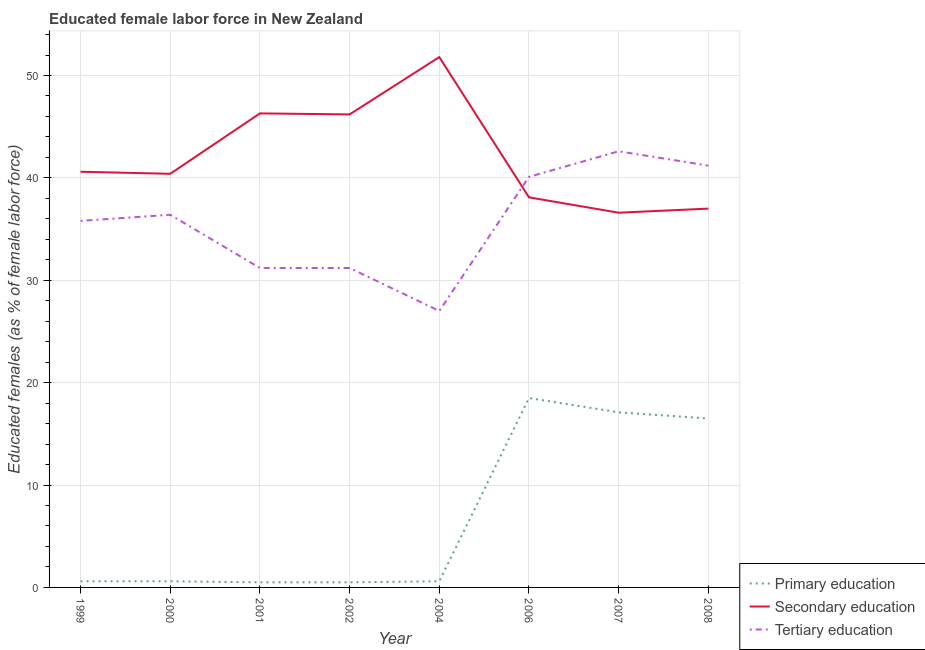How many different coloured lines are there?
Your answer should be compact. 3. What is the percentage of female labor force who received tertiary education in 1999?
Your response must be concise. 35.8. Across all years, what is the maximum percentage of female labor force who received primary education?
Your answer should be compact. 18.5. Across all years, what is the minimum percentage of female labor force who received secondary education?
Provide a succinct answer. 36.6. In which year was the percentage of female labor force who received tertiary education minimum?
Provide a succinct answer. 2004. What is the total percentage of female labor force who received tertiary education in the graph?
Give a very brief answer. 285.5. What is the difference between the percentage of female labor force who received tertiary education in 2007 and that in 2008?
Ensure brevity in your answer.  1.4. What is the difference between the percentage of female labor force who received primary education in 2006 and the percentage of female labor force who received secondary education in 2000?
Make the answer very short. -21.9. What is the average percentage of female labor force who received primary education per year?
Give a very brief answer. 6.86. In the year 2004, what is the difference between the percentage of female labor force who received secondary education and percentage of female labor force who received primary education?
Make the answer very short. 51.2. What is the ratio of the percentage of female labor force who received primary education in 1999 to that in 2006?
Your answer should be compact. 0.03. Is the percentage of female labor force who received secondary education in 2000 less than that in 2006?
Ensure brevity in your answer.  No. What is the difference between the highest and the lowest percentage of female labor force who received tertiary education?
Provide a succinct answer. 15.6. In how many years, is the percentage of female labor force who received tertiary education greater than the average percentage of female labor force who received tertiary education taken over all years?
Make the answer very short. 5. Does the percentage of female labor force who received primary education monotonically increase over the years?
Offer a terse response. No. Is the percentage of female labor force who received secondary education strictly greater than the percentage of female labor force who received primary education over the years?
Ensure brevity in your answer.  Yes. Is the percentage of female labor force who received primary education strictly less than the percentage of female labor force who received tertiary education over the years?
Keep it short and to the point. Yes. How many lines are there?
Keep it short and to the point. 3. Does the graph contain grids?
Provide a short and direct response. Yes. How are the legend labels stacked?
Your answer should be compact. Vertical. What is the title of the graph?
Provide a short and direct response. Educated female labor force in New Zealand. What is the label or title of the X-axis?
Give a very brief answer. Year. What is the label or title of the Y-axis?
Ensure brevity in your answer.  Educated females (as % of female labor force). What is the Educated females (as % of female labor force) of Primary education in 1999?
Provide a short and direct response. 0.6. What is the Educated females (as % of female labor force) of Secondary education in 1999?
Give a very brief answer. 40.6. What is the Educated females (as % of female labor force) of Tertiary education in 1999?
Offer a terse response. 35.8. What is the Educated females (as % of female labor force) in Primary education in 2000?
Keep it short and to the point. 0.6. What is the Educated females (as % of female labor force) in Secondary education in 2000?
Offer a terse response. 40.4. What is the Educated females (as % of female labor force) in Tertiary education in 2000?
Offer a terse response. 36.4. What is the Educated females (as % of female labor force) in Primary education in 2001?
Offer a terse response. 0.5. What is the Educated females (as % of female labor force) of Secondary education in 2001?
Your response must be concise. 46.3. What is the Educated females (as % of female labor force) of Tertiary education in 2001?
Ensure brevity in your answer.  31.2. What is the Educated females (as % of female labor force) of Secondary education in 2002?
Provide a short and direct response. 46.2. What is the Educated females (as % of female labor force) of Tertiary education in 2002?
Provide a succinct answer. 31.2. What is the Educated females (as % of female labor force) in Primary education in 2004?
Provide a short and direct response. 0.6. What is the Educated females (as % of female labor force) in Secondary education in 2004?
Keep it short and to the point. 51.8. What is the Educated females (as % of female labor force) of Tertiary education in 2004?
Provide a succinct answer. 27. What is the Educated females (as % of female labor force) in Secondary education in 2006?
Make the answer very short. 38.1. What is the Educated females (as % of female labor force) in Tertiary education in 2006?
Offer a very short reply. 40.1. What is the Educated females (as % of female labor force) of Primary education in 2007?
Provide a short and direct response. 17.1. What is the Educated females (as % of female labor force) of Secondary education in 2007?
Your answer should be compact. 36.6. What is the Educated females (as % of female labor force) in Tertiary education in 2007?
Keep it short and to the point. 42.6. What is the Educated females (as % of female labor force) in Secondary education in 2008?
Your answer should be compact. 37. What is the Educated females (as % of female labor force) of Tertiary education in 2008?
Offer a terse response. 41.2. Across all years, what is the maximum Educated females (as % of female labor force) of Secondary education?
Provide a succinct answer. 51.8. Across all years, what is the maximum Educated females (as % of female labor force) in Tertiary education?
Provide a succinct answer. 42.6. Across all years, what is the minimum Educated females (as % of female labor force) in Secondary education?
Make the answer very short. 36.6. Across all years, what is the minimum Educated females (as % of female labor force) of Tertiary education?
Ensure brevity in your answer.  27. What is the total Educated females (as % of female labor force) in Primary education in the graph?
Your answer should be compact. 54.9. What is the total Educated females (as % of female labor force) of Secondary education in the graph?
Make the answer very short. 337. What is the total Educated females (as % of female labor force) of Tertiary education in the graph?
Make the answer very short. 285.5. What is the difference between the Educated females (as % of female labor force) in Primary education in 1999 and that in 2000?
Give a very brief answer. 0. What is the difference between the Educated females (as % of female labor force) of Secondary education in 1999 and that in 2000?
Make the answer very short. 0.2. What is the difference between the Educated females (as % of female labor force) of Tertiary education in 1999 and that in 2000?
Offer a very short reply. -0.6. What is the difference between the Educated females (as % of female labor force) of Primary education in 1999 and that in 2001?
Offer a very short reply. 0.1. What is the difference between the Educated females (as % of female labor force) in Secondary education in 1999 and that in 2001?
Make the answer very short. -5.7. What is the difference between the Educated females (as % of female labor force) in Tertiary education in 1999 and that in 2001?
Provide a short and direct response. 4.6. What is the difference between the Educated females (as % of female labor force) in Secondary education in 1999 and that in 2004?
Your response must be concise. -11.2. What is the difference between the Educated females (as % of female labor force) of Primary education in 1999 and that in 2006?
Ensure brevity in your answer.  -17.9. What is the difference between the Educated females (as % of female labor force) of Tertiary education in 1999 and that in 2006?
Your answer should be compact. -4.3. What is the difference between the Educated females (as % of female labor force) of Primary education in 1999 and that in 2007?
Provide a succinct answer. -16.5. What is the difference between the Educated females (as % of female labor force) in Tertiary education in 1999 and that in 2007?
Provide a succinct answer. -6.8. What is the difference between the Educated females (as % of female labor force) of Primary education in 1999 and that in 2008?
Your answer should be very brief. -15.9. What is the difference between the Educated females (as % of female labor force) of Tertiary education in 1999 and that in 2008?
Offer a very short reply. -5.4. What is the difference between the Educated females (as % of female labor force) in Secondary education in 2000 and that in 2001?
Offer a terse response. -5.9. What is the difference between the Educated females (as % of female labor force) of Primary education in 2000 and that in 2002?
Offer a terse response. 0.1. What is the difference between the Educated females (as % of female labor force) in Tertiary education in 2000 and that in 2002?
Make the answer very short. 5.2. What is the difference between the Educated females (as % of female labor force) of Primary education in 2000 and that in 2004?
Your answer should be compact. 0. What is the difference between the Educated females (as % of female labor force) of Primary education in 2000 and that in 2006?
Your response must be concise. -17.9. What is the difference between the Educated females (as % of female labor force) in Secondary education in 2000 and that in 2006?
Give a very brief answer. 2.3. What is the difference between the Educated females (as % of female labor force) of Tertiary education in 2000 and that in 2006?
Keep it short and to the point. -3.7. What is the difference between the Educated females (as % of female labor force) of Primary education in 2000 and that in 2007?
Keep it short and to the point. -16.5. What is the difference between the Educated females (as % of female labor force) of Primary education in 2000 and that in 2008?
Your answer should be compact. -15.9. What is the difference between the Educated females (as % of female labor force) of Secondary education in 2000 and that in 2008?
Provide a short and direct response. 3.4. What is the difference between the Educated females (as % of female labor force) of Secondary education in 2001 and that in 2002?
Make the answer very short. 0.1. What is the difference between the Educated females (as % of female labor force) in Tertiary education in 2001 and that in 2002?
Provide a short and direct response. 0. What is the difference between the Educated females (as % of female labor force) of Secondary education in 2001 and that in 2004?
Keep it short and to the point. -5.5. What is the difference between the Educated females (as % of female labor force) in Primary education in 2001 and that in 2006?
Keep it short and to the point. -18. What is the difference between the Educated females (as % of female labor force) of Primary education in 2001 and that in 2007?
Provide a succinct answer. -16.6. What is the difference between the Educated females (as % of female labor force) in Tertiary education in 2001 and that in 2007?
Your answer should be very brief. -11.4. What is the difference between the Educated females (as % of female labor force) in Primary education in 2001 and that in 2008?
Keep it short and to the point. -16. What is the difference between the Educated females (as % of female labor force) in Secondary education in 2001 and that in 2008?
Offer a terse response. 9.3. What is the difference between the Educated females (as % of female labor force) of Primary education in 2002 and that in 2006?
Provide a short and direct response. -18. What is the difference between the Educated females (as % of female labor force) of Secondary education in 2002 and that in 2006?
Provide a succinct answer. 8.1. What is the difference between the Educated females (as % of female labor force) of Tertiary education in 2002 and that in 2006?
Provide a short and direct response. -8.9. What is the difference between the Educated females (as % of female labor force) in Primary education in 2002 and that in 2007?
Give a very brief answer. -16.6. What is the difference between the Educated females (as % of female labor force) in Secondary education in 2002 and that in 2007?
Give a very brief answer. 9.6. What is the difference between the Educated females (as % of female labor force) of Tertiary education in 2002 and that in 2007?
Give a very brief answer. -11.4. What is the difference between the Educated females (as % of female labor force) in Primary education in 2002 and that in 2008?
Your answer should be compact. -16. What is the difference between the Educated females (as % of female labor force) in Secondary education in 2002 and that in 2008?
Provide a short and direct response. 9.2. What is the difference between the Educated females (as % of female labor force) in Tertiary education in 2002 and that in 2008?
Provide a short and direct response. -10. What is the difference between the Educated females (as % of female labor force) in Primary education in 2004 and that in 2006?
Make the answer very short. -17.9. What is the difference between the Educated females (as % of female labor force) in Tertiary education in 2004 and that in 2006?
Your answer should be very brief. -13.1. What is the difference between the Educated females (as % of female labor force) of Primary education in 2004 and that in 2007?
Your answer should be very brief. -16.5. What is the difference between the Educated females (as % of female labor force) in Tertiary education in 2004 and that in 2007?
Make the answer very short. -15.6. What is the difference between the Educated females (as % of female labor force) of Primary education in 2004 and that in 2008?
Provide a succinct answer. -15.9. What is the difference between the Educated females (as % of female labor force) in Secondary education in 2004 and that in 2008?
Keep it short and to the point. 14.8. What is the difference between the Educated females (as % of female labor force) in Tertiary education in 2004 and that in 2008?
Offer a very short reply. -14.2. What is the difference between the Educated females (as % of female labor force) in Primary education in 2006 and that in 2008?
Make the answer very short. 2. What is the difference between the Educated females (as % of female labor force) in Secondary education in 2006 and that in 2008?
Provide a succinct answer. 1.1. What is the difference between the Educated females (as % of female labor force) in Tertiary education in 2007 and that in 2008?
Offer a very short reply. 1.4. What is the difference between the Educated females (as % of female labor force) of Primary education in 1999 and the Educated females (as % of female labor force) of Secondary education in 2000?
Make the answer very short. -39.8. What is the difference between the Educated females (as % of female labor force) in Primary education in 1999 and the Educated females (as % of female labor force) in Tertiary education in 2000?
Offer a very short reply. -35.8. What is the difference between the Educated females (as % of female labor force) of Secondary education in 1999 and the Educated females (as % of female labor force) of Tertiary education in 2000?
Provide a short and direct response. 4.2. What is the difference between the Educated females (as % of female labor force) in Primary education in 1999 and the Educated females (as % of female labor force) in Secondary education in 2001?
Your response must be concise. -45.7. What is the difference between the Educated females (as % of female labor force) in Primary education in 1999 and the Educated females (as % of female labor force) in Tertiary education in 2001?
Offer a very short reply. -30.6. What is the difference between the Educated females (as % of female labor force) of Secondary education in 1999 and the Educated females (as % of female labor force) of Tertiary education in 2001?
Provide a succinct answer. 9.4. What is the difference between the Educated females (as % of female labor force) in Primary education in 1999 and the Educated females (as % of female labor force) in Secondary education in 2002?
Your answer should be compact. -45.6. What is the difference between the Educated females (as % of female labor force) in Primary education in 1999 and the Educated females (as % of female labor force) in Tertiary education in 2002?
Ensure brevity in your answer.  -30.6. What is the difference between the Educated females (as % of female labor force) of Primary education in 1999 and the Educated females (as % of female labor force) of Secondary education in 2004?
Your response must be concise. -51.2. What is the difference between the Educated females (as % of female labor force) in Primary education in 1999 and the Educated females (as % of female labor force) in Tertiary education in 2004?
Offer a very short reply. -26.4. What is the difference between the Educated females (as % of female labor force) of Primary education in 1999 and the Educated females (as % of female labor force) of Secondary education in 2006?
Your response must be concise. -37.5. What is the difference between the Educated females (as % of female labor force) of Primary education in 1999 and the Educated females (as % of female labor force) of Tertiary education in 2006?
Keep it short and to the point. -39.5. What is the difference between the Educated females (as % of female labor force) of Primary education in 1999 and the Educated females (as % of female labor force) of Secondary education in 2007?
Offer a very short reply. -36. What is the difference between the Educated females (as % of female labor force) of Primary education in 1999 and the Educated females (as % of female labor force) of Tertiary education in 2007?
Provide a succinct answer. -42. What is the difference between the Educated females (as % of female labor force) in Secondary education in 1999 and the Educated females (as % of female labor force) in Tertiary education in 2007?
Provide a succinct answer. -2. What is the difference between the Educated females (as % of female labor force) of Primary education in 1999 and the Educated females (as % of female labor force) of Secondary education in 2008?
Your answer should be compact. -36.4. What is the difference between the Educated females (as % of female labor force) of Primary education in 1999 and the Educated females (as % of female labor force) of Tertiary education in 2008?
Your answer should be compact. -40.6. What is the difference between the Educated females (as % of female labor force) of Secondary education in 1999 and the Educated females (as % of female labor force) of Tertiary education in 2008?
Your response must be concise. -0.6. What is the difference between the Educated females (as % of female labor force) in Primary education in 2000 and the Educated females (as % of female labor force) in Secondary education in 2001?
Offer a terse response. -45.7. What is the difference between the Educated females (as % of female labor force) in Primary education in 2000 and the Educated females (as % of female labor force) in Tertiary education in 2001?
Your answer should be compact. -30.6. What is the difference between the Educated females (as % of female labor force) in Primary education in 2000 and the Educated females (as % of female labor force) in Secondary education in 2002?
Offer a terse response. -45.6. What is the difference between the Educated females (as % of female labor force) in Primary education in 2000 and the Educated females (as % of female labor force) in Tertiary education in 2002?
Keep it short and to the point. -30.6. What is the difference between the Educated females (as % of female labor force) of Secondary education in 2000 and the Educated females (as % of female labor force) of Tertiary education in 2002?
Your answer should be very brief. 9.2. What is the difference between the Educated females (as % of female labor force) of Primary education in 2000 and the Educated females (as % of female labor force) of Secondary education in 2004?
Your response must be concise. -51.2. What is the difference between the Educated females (as % of female labor force) of Primary education in 2000 and the Educated females (as % of female labor force) of Tertiary education in 2004?
Offer a terse response. -26.4. What is the difference between the Educated females (as % of female labor force) in Secondary education in 2000 and the Educated females (as % of female labor force) in Tertiary education in 2004?
Your answer should be very brief. 13.4. What is the difference between the Educated females (as % of female labor force) of Primary education in 2000 and the Educated females (as % of female labor force) of Secondary education in 2006?
Your answer should be compact. -37.5. What is the difference between the Educated females (as % of female labor force) of Primary education in 2000 and the Educated females (as % of female labor force) of Tertiary education in 2006?
Give a very brief answer. -39.5. What is the difference between the Educated females (as % of female labor force) in Secondary education in 2000 and the Educated females (as % of female labor force) in Tertiary education in 2006?
Your answer should be very brief. 0.3. What is the difference between the Educated females (as % of female labor force) in Primary education in 2000 and the Educated females (as % of female labor force) in Secondary education in 2007?
Offer a terse response. -36. What is the difference between the Educated females (as % of female labor force) of Primary education in 2000 and the Educated females (as % of female labor force) of Tertiary education in 2007?
Your answer should be compact. -42. What is the difference between the Educated females (as % of female labor force) in Primary education in 2000 and the Educated females (as % of female labor force) in Secondary education in 2008?
Make the answer very short. -36.4. What is the difference between the Educated females (as % of female labor force) of Primary education in 2000 and the Educated females (as % of female labor force) of Tertiary education in 2008?
Your answer should be very brief. -40.6. What is the difference between the Educated females (as % of female labor force) of Primary education in 2001 and the Educated females (as % of female labor force) of Secondary education in 2002?
Provide a succinct answer. -45.7. What is the difference between the Educated females (as % of female labor force) in Primary education in 2001 and the Educated females (as % of female labor force) in Tertiary education in 2002?
Ensure brevity in your answer.  -30.7. What is the difference between the Educated females (as % of female labor force) of Primary education in 2001 and the Educated females (as % of female labor force) of Secondary education in 2004?
Give a very brief answer. -51.3. What is the difference between the Educated females (as % of female labor force) of Primary education in 2001 and the Educated females (as % of female labor force) of Tertiary education in 2004?
Provide a succinct answer. -26.5. What is the difference between the Educated females (as % of female labor force) of Secondary education in 2001 and the Educated females (as % of female labor force) of Tertiary education in 2004?
Offer a very short reply. 19.3. What is the difference between the Educated females (as % of female labor force) in Primary education in 2001 and the Educated females (as % of female labor force) in Secondary education in 2006?
Provide a succinct answer. -37.6. What is the difference between the Educated females (as % of female labor force) in Primary education in 2001 and the Educated females (as % of female labor force) in Tertiary education in 2006?
Offer a very short reply. -39.6. What is the difference between the Educated females (as % of female labor force) of Primary education in 2001 and the Educated females (as % of female labor force) of Secondary education in 2007?
Keep it short and to the point. -36.1. What is the difference between the Educated females (as % of female labor force) of Primary education in 2001 and the Educated females (as % of female labor force) of Tertiary education in 2007?
Provide a short and direct response. -42.1. What is the difference between the Educated females (as % of female labor force) in Primary education in 2001 and the Educated females (as % of female labor force) in Secondary education in 2008?
Make the answer very short. -36.5. What is the difference between the Educated females (as % of female labor force) of Primary education in 2001 and the Educated females (as % of female labor force) of Tertiary education in 2008?
Offer a terse response. -40.7. What is the difference between the Educated females (as % of female labor force) of Secondary education in 2001 and the Educated females (as % of female labor force) of Tertiary education in 2008?
Give a very brief answer. 5.1. What is the difference between the Educated females (as % of female labor force) of Primary education in 2002 and the Educated females (as % of female labor force) of Secondary education in 2004?
Your response must be concise. -51.3. What is the difference between the Educated females (as % of female labor force) in Primary education in 2002 and the Educated females (as % of female labor force) in Tertiary education in 2004?
Your answer should be compact. -26.5. What is the difference between the Educated females (as % of female labor force) of Primary education in 2002 and the Educated females (as % of female labor force) of Secondary education in 2006?
Provide a short and direct response. -37.6. What is the difference between the Educated females (as % of female labor force) of Primary education in 2002 and the Educated females (as % of female labor force) of Tertiary education in 2006?
Give a very brief answer. -39.6. What is the difference between the Educated females (as % of female labor force) of Primary education in 2002 and the Educated females (as % of female labor force) of Secondary education in 2007?
Make the answer very short. -36.1. What is the difference between the Educated females (as % of female labor force) of Primary education in 2002 and the Educated females (as % of female labor force) of Tertiary education in 2007?
Your answer should be very brief. -42.1. What is the difference between the Educated females (as % of female labor force) of Secondary education in 2002 and the Educated females (as % of female labor force) of Tertiary education in 2007?
Ensure brevity in your answer.  3.6. What is the difference between the Educated females (as % of female labor force) in Primary education in 2002 and the Educated females (as % of female labor force) in Secondary education in 2008?
Keep it short and to the point. -36.5. What is the difference between the Educated females (as % of female labor force) of Primary education in 2002 and the Educated females (as % of female labor force) of Tertiary education in 2008?
Your response must be concise. -40.7. What is the difference between the Educated females (as % of female labor force) in Secondary education in 2002 and the Educated females (as % of female labor force) in Tertiary education in 2008?
Keep it short and to the point. 5. What is the difference between the Educated females (as % of female labor force) of Primary education in 2004 and the Educated females (as % of female labor force) of Secondary education in 2006?
Ensure brevity in your answer.  -37.5. What is the difference between the Educated females (as % of female labor force) of Primary education in 2004 and the Educated females (as % of female labor force) of Tertiary education in 2006?
Make the answer very short. -39.5. What is the difference between the Educated females (as % of female labor force) in Primary education in 2004 and the Educated females (as % of female labor force) in Secondary education in 2007?
Give a very brief answer. -36. What is the difference between the Educated females (as % of female labor force) of Primary education in 2004 and the Educated females (as % of female labor force) of Tertiary education in 2007?
Ensure brevity in your answer.  -42. What is the difference between the Educated females (as % of female labor force) of Primary education in 2004 and the Educated females (as % of female labor force) of Secondary education in 2008?
Make the answer very short. -36.4. What is the difference between the Educated females (as % of female labor force) of Primary education in 2004 and the Educated females (as % of female labor force) of Tertiary education in 2008?
Give a very brief answer. -40.6. What is the difference between the Educated females (as % of female labor force) in Primary education in 2006 and the Educated females (as % of female labor force) in Secondary education in 2007?
Your answer should be compact. -18.1. What is the difference between the Educated females (as % of female labor force) of Primary education in 2006 and the Educated females (as % of female labor force) of Tertiary education in 2007?
Offer a terse response. -24.1. What is the difference between the Educated females (as % of female labor force) of Primary education in 2006 and the Educated females (as % of female labor force) of Secondary education in 2008?
Give a very brief answer. -18.5. What is the difference between the Educated females (as % of female labor force) in Primary education in 2006 and the Educated females (as % of female labor force) in Tertiary education in 2008?
Offer a terse response. -22.7. What is the difference between the Educated females (as % of female labor force) in Secondary education in 2006 and the Educated females (as % of female labor force) in Tertiary education in 2008?
Your response must be concise. -3.1. What is the difference between the Educated females (as % of female labor force) of Primary education in 2007 and the Educated females (as % of female labor force) of Secondary education in 2008?
Make the answer very short. -19.9. What is the difference between the Educated females (as % of female labor force) of Primary education in 2007 and the Educated females (as % of female labor force) of Tertiary education in 2008?
Provide a succinct answer. -24.1. What is the difference between the Educated females (as % of female labor force) of Secondary education in 2007 and the Educated females (as % of female labor force) of Tertiary education in 2008?
Provide a short and direct response. -4.6. What is the average Educated females (as % of female labor force) of Primary education per year?
Your response must be concise. 6.86. What is the average Educated females (as % of female labor force) of Secondary education per year?
Your answer should be very brief. 42.12. What is the average Educated females (as % of female labor force) in Tertiary education per year?
Provide a short and direct response. 35.69. In the year 1999, what is the difference between the Educated females (as % of female labor force) of Primary education and Educated females (as % of female labor force) of Tertiary education?
Your response must be concise. -35.2. In the year 2000, what is the difference between the Educated females (as % of female labor force) of Primary education and Educated females (as % of female labor force) of Secondary education?
Your answer should be very brief. -39.8. In the year 2000, what is the difference between the Educated females (as % of female labor force) of Primary education and Educated females (as % of female labor force) of Tertiary education?
Provide a short and direct response. -35.8. In the year 2000, what is the difference between the Educated females (as % of female labor force) in Secondary education and Educated females (as % of female labor force) in Tertiary education?
Your response must be concise. 4. In the year 2001, what is the difference between the Educated females (as % of female labor force) in Primary education and Educated females (as % of female labor force) in Secondary education?
Your response must be concise. -45.8. In the year 2001, what is the difference between the Educated females (as % of female labor force) in Primary education and Educated females (as % of female labor force) in Tertiary education?
Offer a very short reply. -30.7. In the year 2001, what is the difference between the Educated females (as % of female labor force) in Secondary education and Educated females (as % of female labor force) in Tertiary education?
Your answer should be very brief. 15.1. In the year 2002, what is the difference between the Educated females (as % of female labor force) in Primary education and Educated females (as % of female labor force) in Secondary education?
Your answer should be very brief. -45.7. In the year 2002, what is the difference between the Educated females (as % of female labor force) of Primary education and Educated females (as % of female labor force) of Tertiary education?
Make the answer very short. -30.7. In the year 2004, what is the difference between the Educated females (as % of female labor force) in Primary education and Educated females (as % of female labor force) in Secondary education?
Keep it short and to the point. -51.2. In the year 2004, what is the difference between the Educated females (as % of female labor force) of Primary education and Educated females (as % of female labor force) of Tertiary education?
Provide a short and direct response. -26.4. In the year 2004, what is the difference between the Educated females (as % of female labor force) in Secondary education and Educated females (as % of female labor force) in Tertiary education?
Offer a terse response. 24.8. In the year 2006, what is the difference between the Educated females (as % of female labor force) in Primary education and Educated females (as % of female labor force) in Secondary education?
Give a very brief answer. -19.6. In the year 2006, what is the difference between the Educated females (as % of female labor force) in Primary education and Educated females (as % of female labor force) in Tertiary education?
Give a very brief answer. -21.6. In the year 2006, what is the difference between the Educated females (as % of female labor force) of Secondary education and Educated females (as % of female labor force) of Tertiary education?
Give a very brief answer. -2. In the year 2007, what is the difference between the Educated females (as % of female labor force) in Primary education and Educated females (as % of female labor force) in Secondary education?
Ensure brevity in your answer.  -19.5. In the year 2007, what is the difference between the Educated females (as % of female labor force) in Primary education and Educated females (as % of female labor force) in Tertiary education?
Your answer should be very brief. -25.5. In the year 2007, what is the difference between the Educated females (as % of female labor force) of Secondary education and Educated females (as % of female labor force) of Tertiary education?
Offer a terse response. -6. In the year 2008, what is the difference between the Educated females (as % of female labor force) in Primary education and Educated females (as % of female labor force) in Secondary education?
Provide a succinct answer. -20.5. In the year 2008, what is the difference between the Educated females (as % of female labor force) in Primary education and Educated females (as % of female labor force) in Tertiary education?
Give a very brief answer. -24.7. What is the ratio of the Educated females (as % of female labor force) in Tertiary education in 1999 to that in 2000?
Offer a very short reply. 0.98. What is the ratio of the Educated females (as % of female labor force) of Secondary education in 1999 to that in 2001?
Provide a short and direct response. 0.88. What is the ratio of the Educated females (as % of female labor force) in Tertiary education in 1999 to that in 2001?
Make the answer very short. 1.15. What is the ratio of the Educated females (as % of female labor force) of Primary education in 1999 to that in 2002?
Provide a succinct answer. 1.2. What is the ratio of the Educated females (as % of female labor force) of Secondary education in 1999 to that in 2002?
Your response must be concise. 0.88. What is the ratio of the Educated females (as % of female labor force) in Tertiary education in 1999 to that in 2002?
Your answer should be compact. 1.15. What is the ratio of the Educated females (as % of female labor force) of Secondary education in 1999 to that in 2004?
Offer a terse response. 0.78. What is the ratio of the Educated females (as % of female labor force) of Tertiary education in 1999 to that in 2004?
Your answer should be very brief. 1.33. What is the ratio of the Educated females (as % of female labor force) of Primary education in 1999 to that in 2006?
Make the answer very short. 0.03. What is the ratio of the Educated females (as % of female labor force) of Secondary education in 1999 to that in 2006?
Ensure brevity in your answer.  1.07. What is the ratio of the Educated females (as % of female labor force) of Tertiary education in 1999 to that in 2006?
Offer a terse response. 0.89. What is the ratio of the Educated females (as % of female labor force) in Primary education in 1999 to that in 2007?
Make the answer very short. 0.04. What is the ratio of the Educated females (as % of female labor force) in Secondary education in 1999 to that in 2007?
Your answer should be very brief. 1.11. What is the ratio of the Educated females (as % of female labor force) of Tertiary education in 1999 to that in 2007?
Offer a terse response. 0.84. What is the ratio of the Educated females (as % of female labor force) in Primary education in 1999 to that in 2008?
Provide a succinct answer. 0.04. What is the ratio of the Educated females (as % of female labor force) of Secondary education in 1999 to that in 2008?
Ensure brevity in your answer.  1.1. What is the ratio of the Educated females (as % of female labor force) in Tertiary education in 1999 to that in 2008?
Give a very brief answer. 0.87. What is the ratio of the Educated females (as % of female labor force) of Secondary education in 2000 to that in 2001?
Provide a succinct answer. 0.87. What is the ratio of the Educated females (as % of female labor force) of Tertiary education in 2000 to that in 2001?
Your response must be concise. 1.17. What is the ratio of the Educated females (as % of female labor force) in Primary education in 2000 to that in 2002?
Make the answer very short. 1.2. What is the ratio of the Educated females (as % of female labor force) in Secondary education in 2000 to that in 2002?
Your answer should be compact. 0.87. What is the ratio of the Educated females (as % of female labor force) in Primary education in 2000 to that in 2004?
Your answer should be compact. 1. What is the ratio of the Educated females (as % of female labor force) of Secondary education in 2000 to that in 2004?
Ensure brevity in your answer.  0.78. What is the ratio of the Educated females (as % of female labor force) in Tertiary education in 2000 to that in 2004?
Your answer should be very brief. 1.35. What is the ratio of the Educated females (as % of female labor force) in Primary education in 2000 to that in 2006?
Provide a succinct answer. 0.03. What is the ratio of the Educated females (as % of female labor force) in Secondary education in 2000 to that in 2006?
Give a very brief answer. 1.06. What is the ratio of the Educated females (as % of female labor force) of Tertiary education in 2000 to that in 2006?
Keep it short and to the point. 0.91. What is the ratio of the Educated females (as % of female labor force) of Primary education in 2000 to that in 2007?
Make the answer very short. 0.04. What is the ratio of the Educated females (as % of female labor force) in Secondary education in 2000 to that in 2007?
Make the answer very short. 1.1. What is the ratio of the Educated females (as % of female labor force) of Tertiary education in 2000 to that in 2007?
Your answer should be very brief. 0.85. What is the ratio of the Educated females (as % of female labor force) in Primary education in 2000 to that in 2008?
Keep it short and to the point. 0.04. What is the ratio of the Educated females (as % of female labor force) of Secondary education in 2000 to that in 2008?
Keep it short and to the point. 1.09. What is the ratio of the Educated females (as % of female labor force) in Tertiary education in 2000 to that in 2008?
Offer a very short reply. 0.88. What is the ratio of the Educated females (as % of female labor force) in Primary education in 2001 to that in 2002?
Offer a terse response. 1. What is the ratio of the Educated females (as % of female labor force) of Secondary education in 2001 to that in 2002?
Make the answer very short. 1. What is the ratio of the Educated females (as % of female labor force) of Secondary education in 2001 to that in 2004?
Offer a very short reply. 0.89. What is the ratio of the Educated females (as % of female labor force) of Tertiary education in 2001 to that in 2004?
Offer a very short reply. 1.16. What is the ratio of the Educated females (as % of female labor force) in Primary education in 2001 to that in 2006?
Offer a terse response. 0.03. What is the ratio of the Educated females (as % of female labor force) of Secondary education in 2001 to that in 2006?
Your answer should be compact. 1.22. What is the ratio of the Educated females (as % of female labor force) in Tertiary education in 2001 to that in 2006?
Provide a succinct answer. 0.78. What is the ratio of the Educated females (as % of female labor force) of Primary education in 2001 to that in 2007?
Provide a succinct answer. 0.03. What is the ratio of the Educated females (as % of female labor force) of Secondary education in 2001 to that in 2007?
Offer a terse response. 1.26. What is the ratio of the Educated females (as % of female labor force) in Tertiary education in 2001 to that in 2007?
Your response must be concise. 0.73. What is the ratio of the Educated females (as % of female labor force) in Primary education in 2001 to that in 2008?
Offer a very short reply. 0.03. What is the ratio of the Educated females (as % of female labor force) of Secondary education in 2001 to that in 2008?
Ensure brevity in your answer.  1.25. What is the ratio of the Educated females (as % of female labor force) of Tertiary education in 2001 to that in 2008?
Keep it short and to the point. 0.76. What is the ratio of the Educated females (as % of female labor force) of Primary education in 2002 to that in 2004?
Your answer should be compact. 0.83. What is the ratio of the Educated females (as % of female labor force) in Secondary education in 2002 to that in 2004?
Keep it short and to the point. 0.89. What is the ratio of the Educated females (as % of female labor force) in Tertiary education in 2002 to that in 2004?
Give a very brief answer. 1.16. What is the ratio of the Educated females (as % of female labor force) of Primary education in 2002 to that in 2006?
Your response must be concise. 0.03. What is the ratio of the Educated females (as % of female labor force) in Secondary education in 2002 to that in 2006?
Offer a very short reply. 1.21. What is the ratio of the Educated females (as % of female labor force) in Tertiary education in 2002 to that in 2006?
Your response must be concise. 0.78. What is the ratio of the Educated females (as % of female labor force) in Primary education in 2002 to that in 2007?
Your answer should be very brief. 0.03. What is the ratio of the Educated females (as % of female labor force) in Secondary education in 2002 to that in 2007?
Offer a very short reply. 1.26. What is the ratio of the Educated females (as % of female labor force) in Tertiary education in 2002 to that in 2007?
Give a very brief answer. 0.73. What is the ratio of the Educated females (as % of female labor force) of Primary education in 2002 to that in 2008?
Your response must be concise. 0.03. What is the ratio of the Educated females (as % of female labor force) in Secondary education in 2002 to that in 2008?
Provide a short and direct response. 1.25. What is the ratio of the Educated females (as % of female labor force) in Tertiary education in 2002 to that in 2008?
Offer a terse response. 0.76. What is the ratio of the Educated females (as % of female labor force) of Primary education in 2004 to that in 2006?
Make the answer very short. 0.03. What is the ratio of the Educated females (as % of female labor force) of Secondary education in 2004 to that in 2006?
Offer a very short reply. 1.36. What is the ratio of the Educated females (as % of female labor force) of Tertiary education in 2004 to that in 2006?
Provide a short and direct response. 0.67. What is the ratio of the Educated females (as % of female labor force) in Primary education in 2004 to that in 2007?
Offer a terse response. 0.04. What is the ratio of the Educated females (as % of female labor force) in Secondary education in 2004 to that in 2007?
Offer a terse response. 1.42. What is the ratio of the Educated females (as % of female labor force) in Tertiary education in 2004 to that in 2007?
Offer a terse response. 0.63. What is the ratio of the Educated females (as % of female labor force) of Primary education in 2004 to that in 2008?
Keep it short and to the point. 0.04. What is the ratio of the Educated females (as % of female labor force) in Secondary education in 2004 to that in 2008?
Give a very brief answer. 1.4. What is the ratio of the Educated females (as % of female labor force) in Tertiary education in 2004 to that in 2008?
Give a very brief answer. 0.66. What is the ratio of the Educated females (as % of female labor force) in Primary education in 2006 to that in 2007?
Offer a terse response. 1.08. What is the ratio of the Educated females (as % of female labor force) of Secondary education in 2006 to that in 2007?
Give a very brief answer. 1.04. What is the ratio of the Educated females (as % of female labor force) of Tertiary education in 2006 to that in 2007?
Your response must be concise. 0.94. What is the ratio of the Educated females (as % of female labor force) of Primary education in 2006 to that in 2008?
Ensure brevity in your answer.  1.12. What is the ratio of the Educated females (as % of female labor force) of Secondary education in 2006 to that in 2008?
Provide a succinct answer. 1.03. What is the ratio of the Educated females (as % of female labor force) in Tertiary education in 2006 to that in 2008?
Your answer should be very brief. 0.97. What is the ratio of the Educated females (as % of female labor force) of Primary education in 2007 to that in 2008?
Your response must be concise. 1.04. What is the ratio of the Educated females (as % of female labor force) in Secondary education in 2007 to that in 2008?
Keep it short and to the point. 0.99. What is the ratio of the Educated females (as % of female labor force) of Tertiary education in 2007 to that in 2008?
Your response must be concise. 1.03. What is the difference between the highest and the lowest Educated females (as % of female labor force) of Primary education?
Give a very brief answer. 18. 